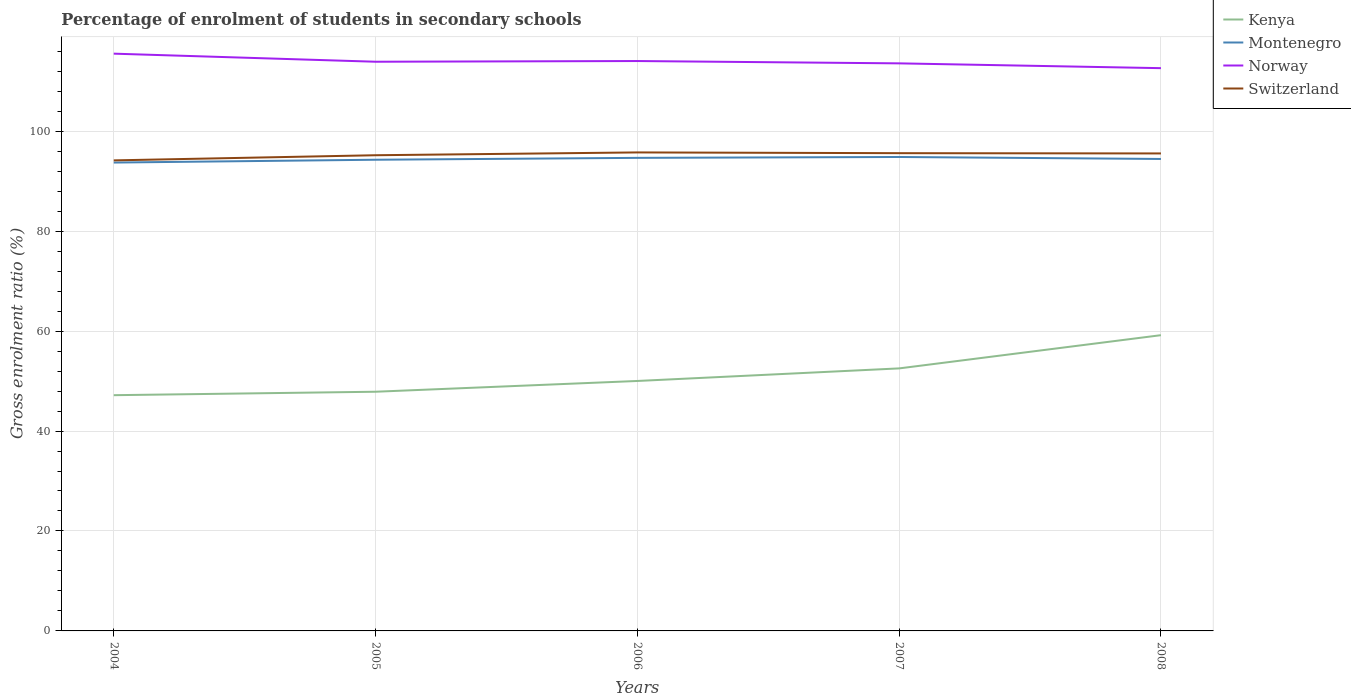How many different coloured lines are there?
Offer a terse response. 4. Does the line corresponding to Montenegro intersect with the line corresponding to Norway?
Your answer should be compact. No. Across all years, what is the maximum percentage of students enrolled in secondary schools in Switzerland?
Make the answer very short. 94.16. What is the total percentage of students enrolled in secondary schools in Switzerland in the graph?
Your answer should be compact. -1.39. What is the difference between the highest and the second highest percentage of students enrolled in secondary schools in Montenegro?
Ensure brevity in your answer.  1.12. How many lines are there?
Keep it short and to the point. 4. How many years are there in the graph?
Make the answer very short. 5. What is the difference between two consecutive major ticks on the Y-axis?
Your answer should be very brief. 20. Does the graph contain grids?
Ensure brevity in your answer.  Yes. Where does the legend appear in the graph?
Your answer should be compact. Top right. How are the legend labels stacked?
Your answer should be very brief. Vertical. What is the title of the graph?
Offer a terse response. Percentage of enrolment of students in secondary schools. Does "World" appear as one of the legend labels in the graph?
Offer a terse response. No. What is the label or title of the X-axis?
Make the answer very short. Years. What is the Gross enrolment ratio (%) in Kenya in 2004?
Ensure brevity in your answer.  47.17. What is the Gross enrolment ratio (%) of Montenegro in 2004?
Your answer should be very brief. 93.72. What is the Gross enrolment ratio (%) of Norway in 2004?
Make the answer very short. 115.52. What is the Gross enrolment ratio (%) in Switzerland in 2004?
Your response must be concise. 94.16. What is the Gross enrolment ratio (%) of Kenya in 2005?
Your response must be concise. 47.86. What is the Gross enrolment ratio (%) of Montenegro in 2005?
Make the answer very short. 94.29. What is the Gross enrolment ratio (%) of Norway in 2005?
Provide a succinct answer. 113.9. What is the Gross enrolment ratio (%) in Switzerland in 2005?
Offer a terse response. 95.19. What is the Gross enrolment ratio (%) of Kenya in 2006?
Your answer should be very brief. 50.02. What is the Gross enrolment ratio (%) of Montenegro in 2006?
Keep it short and to the point. 94.66. What is the Gross enrolment ratio (%) in Norway in 2006?
Your response must be concise. 114.04. What is the Gross enrolment ratio (%) of Switzerland in 2006?
Provide a succinct answer. 95.75. What is the Gross enrolment ratio (%) of Kenya in 2007?
Your answer should be very brief. 52.53. What is the Gross enrolment ratio (%) in Montenegro in 2007?
Provide a short and direct response. 94.84. What is the Gross enrolment ratio (%) of Norway in 2007?
Ensure brevity in your answer.  113.58. What is the Gross enrolment ratio (%) of Switzerland in 2007?
Give a very brief answer. 95.6. What is the Gross enrolment ratio (%) in Kenya in 2008?
Make the answer very short. 59.18. What is the Gross enrolment ratio (%) of Montenegro in 2008?
Your answer should be compact. 94.44. What is the Gross enrolment ratio (%) in Norway in 2008?
Offer a very short reply. 112.61. What is the Gross enrolment ratio (%) of Switzerland in 2008?
Offer a terse response. 95.55. Across all years, what is the maximum Gross enrolment ratio (%) in Kenya?
Your answer should be compact. 59.18. Across all years, what is the maximum Gross enrolment ratio (%) in Montenegro?
Give a very brief answer. 94.84. Across all years, what is the maximum Gross enrolment ratio (%) in Norway?
Give a very brief answer. 115.52. Across all years, what is the maximum Gross enrolment ratio (%) of Switzerland?
Your response must be concise. 95.75. Across all years, what is the minimum Gross enrolment ratio (%) in Kenya?
Keep it short and to the point. 47.17. Across all years, what is the minimum Gross enrolment ratio (%) in Montenegro?
Make the answer very short. 93.72. Across all years, what is the minimum Gross enrolment ratio (%) in Norway?
Offer a terse response. 112.61. Across all years, what is the minimum Gross enrolment ratio (%) of Switzerland?
Keep it short and to the point. 94.16. What is the total Gross enrolment ratio (%) of Kenya in the graph?
Provide a succinct answer. 256.77. What is the total Gross enrolment ratio (%) of Montenegro in the graph?
Provide a short and direct response. 471.96. What is the total Gross enrolment ratio (%) in Norway in the graph?
Make the answer very short. 569.65. What is the total Gross enrolment ratio (%) in Switzerland in the graph?
Provide a succinct answer. 476.26. What is the difference between the Gross enrolment ratio (%) in Kenya in 2004 and that in 2005?
Provide a succinct answer. -0.69. What is the difference between the Gross enrolment ratio (%) of Montenegro in 2004 and that in 2005?
Offer a terse response. -0.56. What is the difference between the Gross enrolment ratio (%) of Norway in 2004 and that in 2005?
Offer a terse response. 1.62. What is the difference between the Gross enrolment ratio (%) in Switzerland in 2004 and that in 2005?
Offer a very short reply. -1.03. What is the difference between the Gross enrolment ratio (%) in Kenya in 2004 and that in 2006?
Offer a terse response. -2.84. What is the difference between the Gross enrolment ratio (%) in Montenegro in 2004 and that in 2006?
Your answer should be very brief. -0.94. What is the difference between the Gross enrolment ratio (%) in Norway in 2004 and that in 2006?
Make the answer very short. 1.48. What is the difference between the Gross enrolment ratio (%) of Switzerland in 2004 and that in 2006?
Your response must be concise. -1.59. What is the difference between the Gross enrolment ratio (%) of Kenya in 2004 and that in 2007?
Provide a succinct answer. -5.36. What is the difference between the Gross enrolment ratio (%) in Montenegro in 2004 and that in 2007?
Make the answer very short. -1.12. What is the difference between the Gross enrolment ratio (%) in Norway in 2004 and that in 2007?
Provide a succinct answer. 1.94. What is the difference between the Gross enrolment ratio (%) in Switzerland in 2004 and that in 2007?
Make the answer very short. -1.44. What is the difference between the Gross enrolment ratio (%) of Kenya in 2004 and that in 2008?
Your answer should be compact. -12.01. What is the difference between the Gross enrolment ratio (%) of Montenegro in 2004 and that in 2008?
Offer a very short reply. -0.72. What is the difference between the Gross enrolment ratio (%) of Norway in 2004 and that in 2008?
Give a very brief answer. 2.9. What is the difference between the Gross enrolment ratio (%) in Switzerland in 2004 and that in 2008?
Your answer should be very brief. -1.39. What is the difference between the Gross enrolment ratio (%) in Kenya in 2005 and that in 2006?
Offer a terse response. -2.15. What is the difference between the Gross enrolment ratio (%) in Montenegro in 2005 and that in 2006?
Offer a terse response. -0.38. What is the difference between the Gross enrolment ratio (%) of Norway in 2005 and that in 2006?
Your answer should be very brief. -0.14. What is the difference between the Gross enrolment ratio (%) of Switzerland in 2005 and that in 2006?
Offer a terse response. -0.56. What is the difference between the Gross enrolment ratio (%) of Kenya in 2005 and that in 2007?
Offer a terse response. -4.67. What is the difference between the Gross enrolment ratio (%) in Montenegro in 2005 and that in 2007?
Offer a terse response. -0.55. What is the difference between the Gross enrolment ratio (%) in Norway in 2005 and that in 2007?
Give a very brief answer. 0.32. What is the difference between the Gross enrolment ratio (%) in Switzerland in 2005 and that in 2007?
Ensure brevity in your answer.  -0.41. What is the difference between the Gross enrolment ratio (%) of Kenya in 2005 and that in 2008?
Ensure brevity in your answer.  -11.32. What is the difference between the Gross enrolment ratio (%) of Montenegro in 2005 and that in 2008?
Offer a very short reply. -0.15. What is the difference between the Gross enrolment ratio (%) of Norway in 2005 and that in 2008?
Provide a succinct answer. 1.29. What is the difference between the Gross enrolment ratio (%) of Switzerland in 2005 and that in 2008?
Make the answer very short. -0.36. What is the difference between the Gross enrolment ratio (%) of Kenya in 2006 and that in 2007?
Offer a very short reply. -2.52. What is the difference between the Gross enrolment ratio (%) in Montenegro in 2006 and that in 2007?
Ensure brevity in your answer.  -0.18. What is the difference between the Gross enrolment ratio (%) of Norway in 2006 and that in 2007?
Your answer should be very brief. 0.47. What is the difference between the Gross enrolment ratio (%) of Switzerland in 2006 and that in 2007?
Give a very brief answer. 0.15. What is the difference between the Gross enrolment ratio (%) of Kenya in 2006 and that in 2008?
Your answer should be very brief. -9.16. What is the difference between the Gross enrolment ratio (%) of Montenegro in 2006 and that in 2008?
Your answer should be compact. 0.22. What is the difference between the Gross enrolment ratio (%) of Norway in 2006 and that in 2008?
Give a very brief answer. 1.43. What is the difference between the Gross enrolment ratio (%) in Switzerland in 2006 and that in 2008?
Provide a succinct answer. 0.2. What is the difference between the Gross enrolment ratio (%) in Kenya in 2007 and that in 2008?
Your answer should be compact. -6.65. What is the difference between the Gross enrolment ratio (%) of Montenegro in 2007 and that in 2008?
Offer a terse response. 0.4. What is the difference between the Gross enrolment ratio (%) in Norway in 2007 and that in 2008?
Your answer should be very brief. 0.96. What is the difference between the Gross enrolment ratio (%) of Switzerland in 2007 and that in 2008?
Give a very brief answer. 0.05. What is the difference between the Gross enrolment ratio (%) of Kenya in 2004 and the Gross enrolment ratio (%) of Montenegro in 2005?
Your response must be concise. -47.12. What is the difference between the Gross enrolment ratio (%) of Kenya in 2004 and the Gross enrolment ratio (%) of Norway in 2005?
Ensure brevity in your answer.  -66.73. What is the difference between the Gross enrolment ratio (%) of Kenya in 2004 and the Gross enrolment ratio (%) of Switzerland in 2005?
Make the answer very short. -48.02. What is the difference between the Gross enrolment ratio (%) in Montenegro in 2004 and the Gross enrolment ratio (%) in Norway in 2005?
Provide a short and direct response. -20.18. What is the difference between the Gross enrolment ratio (%) in Montenegro in 2004 and the Gross enrolment ratio (%) in Switzerland in 2005?
Your answer should be very brief. -1.47. What is the difference between the Gross enrolment ratio (%) in Norway in 2004 and the Gross enrolment ratio (%) in Switzerland in 2005?
Give a very brief answer. 20.33. What is the difference between the Gross enrolment ratio (%) of Kenya in 2004 and the Gross enrolment ratio (%) of Montenegro in 2006?
Offer a terse response. -47.49. What is the difference between the Gross enrolment ratio (%) in Kenya in 2004 and the Gross enrolment ratio (%) in Norway in 2006?
Make the answer very short. -66.87. What is the difference between the Gross enrolment ratio (%) in Kenya in 2004 and the Gross enrolment ratio (%) in Switzerland in 2006?
Ensure brevity in your answer.  -48.58. What is the difference between the Gross enrolment ratio (%) of Montenegro in 2004 and the Gross enrolment ratio (%) of Norway in 2006?
Offer a terse response. -20.32. What is the difference between the Gross enrolment ratio (%) in Montenegro in 2004 and the Gross enrolment ratio (%) in Switzerland in 2006?
Keep it short and to the point. -2.03. What is the difference between the Gross enrolment ratio (%) of Norway in 2004 and the Gross enrolment ratio (%) of Switzerland in 2006?
Offer a very short reply. 19.76. What is the difference between the Gross enrolment ratio (%) of Kenya in 2004 and the Gross enrolment ratio (%) of Montenegro in 2007?
Provide a succinct answer. -47.67. What is the difference between the Gross enrolment ratio (%) in Kenya in 2004 and the Gross enrolment ratio (%) in Norway in 2007?
Your response must be concise. -66.4. What is the difference between the Gross enrolment ratio (%) in Kenya in 2004 and the Gross enrolment ratio (%) in Switzerland in 2007?
Ensure brevity in your answer.  -48.43. What is the difference between the Gross enrolment ratio (%) of Montenegro in 2004 and the Gross enrolment ratio (%) of Norway in 2007?
Your answer should be compact. -19.85. What is the difference between the Gross enrolment ratio (%) in Montenegro in 2004 and the Gross enrolment ratio (%) in Switzerland in 2007?
Offer a very short reply. -1.88. What is the difference between the Gross enrolment ratio (%) in Norway in 2004 and the Gross enrolment ratio (%) in Switzerland in 2007?
Make the answer very short. 19.91. What is the difference between the Gross enrolment ratio (%) of Kenya in 2004 and the Gross enrolment ratio (%) of Montenegro in 2008?
Provide a succinct answer. -47.27. What is the difference between the Gross enrolment ratio (%) of Kenya in 2004 and the Gross enrolment ratio (%) of Norway in 2008?
Your answer should be very brief. -65.44. What is the difference between the Gross enrolment ratio (%) in Kenya in 2004 and the Gross enrolment ratio (%) in Switzerland in 2008?
Provide a succinct answer. -48.38. What is the difference between the Gross enrolment ratio (%) of Montenegro in 2004 and the Gross enrolment ratio (%) of Norway in 2008?
Ensure brevity in your answer.  -18.89. What is the difference between the Gross enrolment ratio (%) in Montenegro in 2004 and the Gross enrolment ratio (%) in Switzerland in 2008?
Offer a very short reply. -1.82. What is the difference between the Gross enrolment ratio (%) of Norway in 2004 and the Gross enrolment ratio (%) of Switzerland in 2008?
Provide a short and direct response. 19.97. What is the difference between the Gross enrolment ratio (%) of Kenya in 2005 and the Gross enrolment ratio (%) of Montenegro in 2006?
Make the answer very short. -46.8. What is the difference between the Gross enrolment ratio (%) of Kenya in 2005 and the Gross enrolment ratio (%) of Norway in 2006?
Provide a short and direct response. -66.18. What is the difference between the Gross enrolment ratio (%) in Kenya in 2005 and the Gross enrolment ratio (%) in Switzerland in 2006?
Your answer should be compact. -47.89. What is the difference between the Gross enrolment ratio (%) in Montenegro in 2005 and the Gross enrolment ratio (%) in Norway in 2006?
Provide a short and direct response. -19.75. What is the difference between the Gross enrolment ratio (%) of Montenegro in 2005 and the Gross enrolment ratio (%) of Switzerland in 2006?
Keep it short and to the point. -1.46. What is the difference between the Gross enrolment ratio (%) of Norway in 2005 and the Gross enrolment ratio (%) of Switzerland in 2006?
Provide a short and direct response. 18.15. What is the difference between the Gross enrolment ratio (%) in Kenya in 2005 and the Gross enrolment ratio (%) in Montenegro in 2007?
Your answer should be compact. -46.98. What is the difference between the Gross enrolment ratio (%) of Kenya in 2005 and the Gross enrolment ratio (%) of Norway in 2007?
Keep it short and to the point. -65.71. What is the difference between the Gross enrolment ratio (%) of Kenya in 2005 and the Gross enrolment ratio (%) of Switzerland in 2007?
Ensure brevity in your answer.  -47.74. What is the difference between the Gross enrolment ratio (%) in Montenegro in 2005 and the Gross enrolment ratio (%) in Norway in 2007?
Keep it short and to the point. -19.29. What is the difference between the Gross enrolment ratio (%) in Montenegro in 2005 and the Gross enrolment ratio (%) in Switzerland in 2007?
Offer a very short reply. -1.31. What is the difference between the Gross enrolment ratio (%) in Norway in 2005 and the Gross enrolment ratio (%) in Switzerland in 2007?
Your answer should be very brief. 18.3. What is the difference between the Gross enrolment ratio (%) of Kenya in 2005 and the Gross enrolment ratio (%) of Montenegro in 2008?
Offer a very short reply. -46.58. What is the difference between the Gross enrolment ratio (%) of Kenya in 2005 and the Gross enrolment ratio (%) of Norway in 2008?
Keep it short and to the point. -64.75. What is the difference between the Gross enrolment ratio (%) of Kenya in 2005 and the Gross enrolment ratio (%) of Switzerland in 2008?
Provide a short and direct response. -47.69. What is the difference between the Gross enrolment ratio (%) in Montenegro in 2005 and the Gross enrolment ratio (%) in Norway in 2008?
Your response must be concise. -18.32. What is the difference between the Gross enrolment ratio (%) of Montenegro in 2005 and the Gross enrolment ratio (%) of Switzerland in 2008?
Ensure brevity in your answer.  -1.26. What is the difference between the Gross enrolment ratio (%) of Norway in 2005 and the Gross enrolment ratio (%) of Switzerland in 2008?
Ensure brevity in your answer.  18.35. What is the difference between the Gross enrolment ratio (%) of Kenya in 2006 and the Gross enrolment ratio (%) of Montenegro in 2007?
Offer a very short reply. -44.82. What is the difference between the Gross enrolment ratio (%) of Kenya in 2006 and the Gross enrolment ratio (%) of Norway in 2007?
Make the answer very short. -63.56. What is the difference between the Gross enrolment ratio (%) in Kenya in 2006 and the Gross enrolment ratio (%) in Switzerland in 2007?
Ensure brevity in your answer.  -45.59. What is the difference between the Gross enrolment ratio (%) of Montenegro in 2006 and the Gross enrolment ratio (%) of Norway in 2007?
Your response must be concise. -18.91. What is the difference between the Gross enrolment ratio (%) of Montenegro in 2006 and the Gross enrolment ratio (%) of Switzerland in 2007?
Offer a very short reply. -0.94. What is the difference between the Gross enrolment ratio (%) in Norway in 2006 and the Gross enrolment ratio (%) in Switzerland in 2007?
Your answer should be very brief. 18.44. What is the difference between the Gross enrolment ratio (%) in Kenya in 2006 and the Gross enrolment ratio (%) in Montenegro in 2008?
Give a very brief answer. -44.43. What is the difference between the Gross enrolment ratio (%) of Kenya in 2006 and the Gross enrolment ratio (%) of Norway in 2008?
Ensure brevity in your answer.  -62.6. What is the difference between the Gross enrolment ratio (%) in Kenya in 2006 and the Gross enrolment ratio (%) in Switzerland in 2008?
Make the answer very short. -45.53. What is the difference between the Gross enrolment ratio (%) of Montenegro in 2006 and the Gross enrolment ratio (%) of Norway in 2008?
Provide a short and direct response. -17.95. What is the difference between the Gross enrolment ratio (%) of Montenegro in 2006 and the Gross enrolment ratio (%) of Switzerland in 2008?
Provide a short and direct response. -0.88. What is the difference between the Gross enrolment ratio (%) in Norway in 2006 and the Gross enrolment ratio (%) in Switzerland in 2008?
Your response must be concise. 18.49. What is the difference between the Gross enrolment ratio (%) in Kenya in 2007 and the Gross enrolment ratio (%) in Montenegro in 2008?
Your response must be concise. -41.91. What is the difference between the Gross enrolment ratio (%) in Kenya in 2007 and the Gross enrolment ratio (%) in Norway in 2008?
Offer a very short reply. -60.08. What is the difference between the Gross enrolment ratio (%) in Kenya in 2007 and the Gross enrolment ratio (%) in Switzerland in 2008?
Your response must be concise. -43.01. What is the difference between the Gross enrolment ratio (%) in Montenegro in 2007 and the Gross enrolment ratio (%) in Norway in 2008?
Make the answer very short. -17.77. What is the difference between the Gross enrolment ratio (%) in Montenegro in 2007 and the Gross enrolment ratio (%) in Switzerland in 2008?
Offer a very short reply. -0.71. What is the difference between the Gross enrolment ratio (%) in Norway in 2007 and the Gross enrolment ratio (%) in Switzerland in 2008?
Give a very brief answer. 18.03. What is the average Gross enrolment ratio (%) in Kenya per year?
Give a very brief answer. 51.35. What is the average Gross enrolment ratio (%) in Montenegro per year?
Your response must be concise. 94.39. What is the average Gross enrolment ratio (%) in Norway per year?
Provide a succinct answer. 113.93. What is the average Gross enrolment ratio (%) in Switzerland per year?
Give a very brief answer. 95.25. In the year 2004, what is the difference between the Gross enrolment ratio (%) in Kenya and Gross enrolment ratio (%) in Montenegro?
Offer a terse response. -46.55. In the year 2004, what is the difference between the Gross enrolment ratio (%) in Kenya and Gross enrolment ratio (%) in Norway?
Make the answer very short. -68.34. In the year 2004, what is the difference between the Gross enrolment ratio (%) in Kenya and Gross enrolment ratio (%) in Switzerland?
Keep it short and to the point. -46.99. In the year 2004, what is the difference between the Gross enrolment ratio (%) of Montenegro and Gross enrolment ratio (%) of Norway?
Provide a short and direct response. -21.79. In the year 2004, what is the difference between the Gross enrolment ratio (%) of Montenegro and Gross enrolment ratio (%) of Switzerland?
Keep it short and to the point. -0.44. In the year 2004, what is the difference between the Gross enrolment ratio (%) of Norway and Gross enrolment ratio (%) of Switzerland?
Make the answer very short. 21.36. In the year 2005, what is the difference between the Gross enrolment ratio (%) in Kenya and Gross enrolment ratio (%) in Montenegro?
Provide a succinct answer. -46.43. In the year 2005, what is the difference between the Gross enrolment ratio (%) of Kenya and Gross enrolment ratio (%) of Norway?
Your answer should be very brief. -66.04. In the year 2005, what is the difference between the Gross enrolment ratio (%) in Kenya and Gross enrolment ratio (%) in Switzerland?
Ensure brevity in your answer.  -47.33. In the year 2005, what is the difference between the Gross enrolment ratio (%) in Montenegro and Gross enrolment ratio (%) in Norway?
Offer a terse response. -19.61. In the year 2005, what is the difference between the Gross enrolment ratio (%) in Montenegro and Gross enrolment ratio (%) in Switzerland?
Your response must be concise. -0.9. In the year 2005, what is the difference between the Gross enrolment ratio (%) of Norway and Gross enrolment ratio (%) of Switzerland?
Keep it short and to the point. 18.71. In the year 2006, what is the difference between the Gross enrolment ratio (%) in Kenya and Gross enrolment ratio (%) in Montenegro?
Ensure brevity in your answer.  -44.65. In the year 2006, what is the difference between the Gross enrolment ratio (%) of Kenya and Gross enrolment ratio (%) of Norway?
Ensure brevity in your answer.  -64.02. In the year 2006, what is the difference between the Gross enrolment ratio (%) in Kenya and Gross enrolment ratio (%) in Switzerland?
Ensure brevity in your answer.  -45.74. In the year 2006, what is the difference between the Gross enrolment ratio (%) in Montenegro and Gross enrolment ratio (%) in Norway?
Keep it short and to the point. -19.38. In the year 2006, what is the difference between the Gross enrolment ratio (%) of Montenegro and Gross enrolment ratio (%) of Switzerland?
Give a very brief answer. -1.09. In the year 2006, what is the difference between the Gross enrolment ratio (%) in Norway and Gross enrolment ratio (%) in Switzerland?
Provide a succinct answer. 18.29. In the year 2007, what is the difference between the Gross enrolment ratio (%) of Kenya and Gross enrolment ratio (%) of Montenegro?
Offer a very short reply. -42.31. In the year 2007, what is the difference between the Gross enrolment ratio (%) in Kenya and Gross enrolment ratio (%) in Norway?
Give a very brief answer. -61.04. In the year 2007, what is the difference between the Gross enrolment ratio (%) of Kenya and Gross enrolment ratio (%) of Switzerland?
Keep it short and to the point. -43.07. In the year 2007, what is the difference between the Gross enrolment ratio (%) of Montenegro and Gross enrolment ratio (%) of Norway?
Offer a terse response. -18.73. In the year 2007, what is the difference between the Gross enrolment ratio (%) of Montenegro and Gross enrolment ratio (%) of Switzerland?
Ensure brevity in your answer.  -0.76. In the year 2007, what is the difference between the Gross enrolment ratio (%) of Norway and Gross enrolment ratio (%) of Switzerland?
Keep it short and to the point. 17.97. In the year 2008, what is the difference between the Gross enrolment ratio (%) of Kenya and Gross enrolment ratio (%) of Montenegro?
Your answer should be very brief. -35.26. In the year 2008, what is the difference between the Gross enrolment ratio (%) of Kenya and Gross enrolment ratio (%) of Norway?
Keep it short and to the point. -53.43. In the year 2008, what is the difference between the Gross enrolment ratio (%) in Kenya and Gross enrolment ratio (%) in Switzerland?
Your answer should be compact. -36.37. In the year 2008, what is the difference between the Gross enrolment ratio (%) in Montenegro and Gross enrolment ratio (%) in Norway?
Keep it short and to the point. -18.17. In the year 2008, what is the difference between the Gross enrolment ratio (%) of Montenegro and Gross enrolment ratio (%) of Switzerland?
Keep it short and to the point. -1.11. In the year 2008, what is the difference between the Gross enrolment ratio (%) of Norway and Gross enrolment ratio (%) of Switzerland?
Your answer should be compact. 17.07. What is the ratio of the Gross enrolment ratio (%) in Kenya in 2004 to that in 2005?
Give a very brief answer. 0.99. What is the ratio of the Gross enrolment ratio (%) in Montenegro in 2004 to that in 2005?
Make the answer very short. 0.99. What is the ratio of the Gross enrolment ratio (%) of Norway in 2004 to that in 2005?
Offer a terse response. 1.01. What is the ratio of the Gross enrolment ratio (%) of Kenya in 2004 to that in 2006?
Provide a short and direct response. 0.94. What is the ratio of the Gross enrolment ratio (%) in Norway in 2004 to that in 2006?
Ensure brevity in your answer.  1.01. What is the ratio of the Gross enrolment ratio (%) of Switzerland in 2004 to that in 2006?
Give a very brief answer. 0.98. What is the ratio of the Gross enrolment ratio (%) of Kenya in 2004 to that in 2007?
Ensure brevity in your answer.  0.9. What is the ratio of the Gross enrolment ratio (%) in Montenegro in 2004 to that in 2007?
Provide a short and direct response. 0.99. What is the ratio of the Gross enrolment ratio (%) in Norway in 2004 to that in 2007?
Give a very brief answer. 1.02. What is the ratio of the Gross enrolment ratio (%) of Switzerland in 2004 to that in 2007?
Provide a short and direct response. 0.98. What is the ratio of the Gross enrolment ratio (%) in Kenya in 2004 to that in 2008?
Make the answer very short. 0.8. What is the ratio of the Gross enrolment ratio (%) in Montenegro in 2004 to that in 2008?
Make the answer very short. 0.99. What is the ratio of the Gross enrolment ratio (%) of Norway in 2004 to that in 2008?
Your response must be concise. 1.03. What is the ratio of the Gross enrolment ratio (%) in Switzerland in 2004 to that in 2008?
Provide a short and direct response. 0.99. What is the ratio of the Gross enrolment ratio (%) in Kenya in 2005 to that in 2006?
Your response must be concise. 0.96. What is the ratio of the Gross enrolment ratio (%) in Norway in 2005 to that in 2006?
Make the answer very short. 1. What is the ratio of the Gross enrolment ratio (%) of Switzerland in 2005 to that in 2006?
Give a very brief answer. 0.99. What is the ratio of the Gross enrolment ratio (%) in Kenya in 2005 to that in 2007?
Ensure brevity in your answer.  0.91. What is the ratio of the Gross enrolment ratio (%) of Montenegro in 2005 to that in 2007?
Ensure brevity in your answer.  0.99. What is the ratio of the Gross enrolment ratio (%) of Kenya in 2005 to that in 2008?
Provide a short and direct response. 0.81. What is the ratio of the Gross enrolment ratio (%) in Norway in 2005 to that in 2008?
Make the answer very short. 1.01. What is the ratio of the Gross enrolment ratio (%) of Switzerland in 2005 to that in 2008?
Your response must be concise. 1. What is the ratio of the Gross enrolment ratio (%) in Kenya in 2006 to that in 2007?
Ensure brevity in your answer.  0.95. What is the ratio of the Gross enrolment ratio (%) in Norway in 2006 to that in 2007?
Keep it short and to the point. 1. What is the ratio of the Gross enrolment ratio (%) in Kenya in 2006 to that in 2008?
Make the answer very short. 0.85. What is the ratio of the Gross enrolment ratio (%) of Montenegro in 2006 to that in 2008?
Ensure brevity in your answer.  1. What is the ratio of the Gross enrolment ratio (%) of Norway in 2006 to that in 2008?
Provide a short and direct response. 1.01. What is the ratio of the Gross enrolment ratio (%) of Kenya in 2007 to that in 2008?
Provide a succinct answer. 0.89. What is the ratio of the Gross enrolment ratio (%) of Montenegro in 2007 to that in 2008?
Ensure brevity in your answer.  1. What is the ratio of the Gross enrolment ratio (%) in Norway in 2007 to that in 2008?
Give a very brief answer. 1.01. What is the difference between the highest and the second highest Gross enrolment ratio (%) of Kenya?
Your answer should be very brief. 6.65. What is the difference between the highest and the second highest Gross enrolment ratio (%) in Montenegro?
Your answer should be very brief. 0.18. What is the difference between the highest and the second highest Gross enrolment ratio (%) of Norway?
Offer a terse response. 1.48. What is the difference between the highest and the second highest Gross enrolment ratio (%) of Switzerland?
Offer a very short reply. 0.15. What is the difference between the highest and the lowest Gross enrolment ratio (%) of Kenya?
Your answer should be compact. 12.01. What is the difference between the highest and the lowest Gross enrolment ratio (%) of Montenegro?
Your response must be concise. 1.12. What is the difference between the highest and the lowest Gross enrolment ratio (%) of Norway?
Your response must be concise. 2.9. What is the difference between the highest and the lowest Gross enrolment ratio (%) in Switzerland?
Keep it short and to the point. 1.59. 